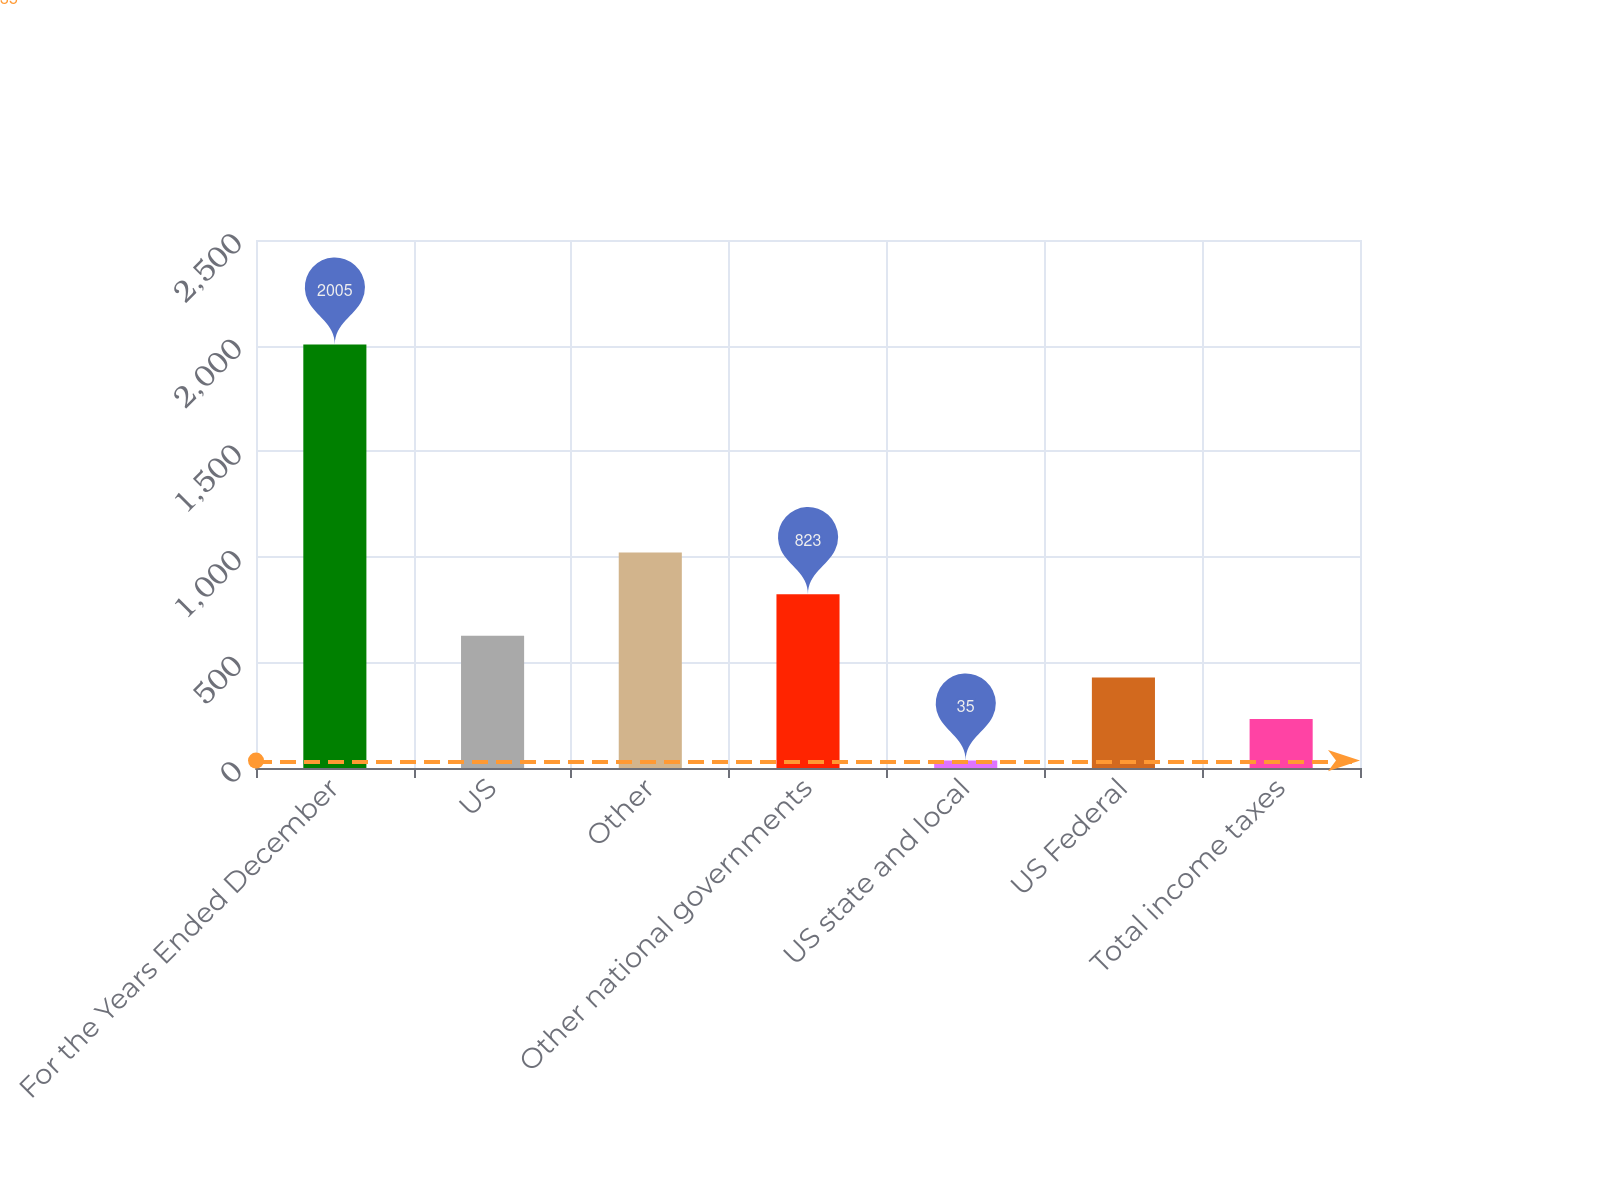Convert chart to OTSL. <chart><loc_0><loc_0><loc_500><loc_500><bar_chart><fcel>For the Years Ended December<fcel>US<fcel>Other<fcel>Other national governments<fcel>US state and local<fcel>US Federal<fcel>Total income taxes<nl><fcel>2005<fcel>626<fcel>1020<fcel>823<fcel>35<fcel>429<fcel>232<nl></chart> 